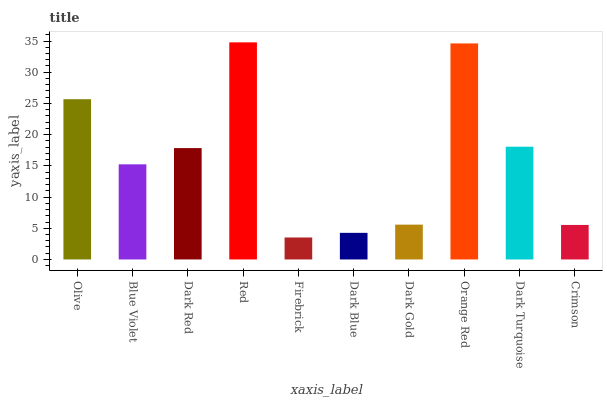Is Firebrick the minimum?
Answer yes or no. Yes. Is Red the maximum?
Answer yes or no. Yes. Is Blue Violet the minimum?
Answer yes or no. No. Is Blue Violet the maximum?
Answer yes or no. No. Is Olive greater than Blue Violet?
Answer yes or no. Yes. Is Blue Violet less than Olive?
Answer yes or no. Yes. Is Blue Violet greater than Olive?
Answer yes or no. No. Is Olive less than Blue Violet?
Answer yes or no. No. Is Dark Red the high median?
Answer yes or no. Yes. Is Blue Violet the low median?
Answer yes or no. Yes. Is Crimson the high median?
Answer yes or no. No. Is Orange Red the low median?
Answer yes or no. No. 